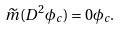Convert formula to latex. <formula><loc_0><loc_0><loc_500><loc_500>\widetilde { m } ( D ^ { 2 } \phi _ { c } ) = 0 \phi _ { c } .</formula> 